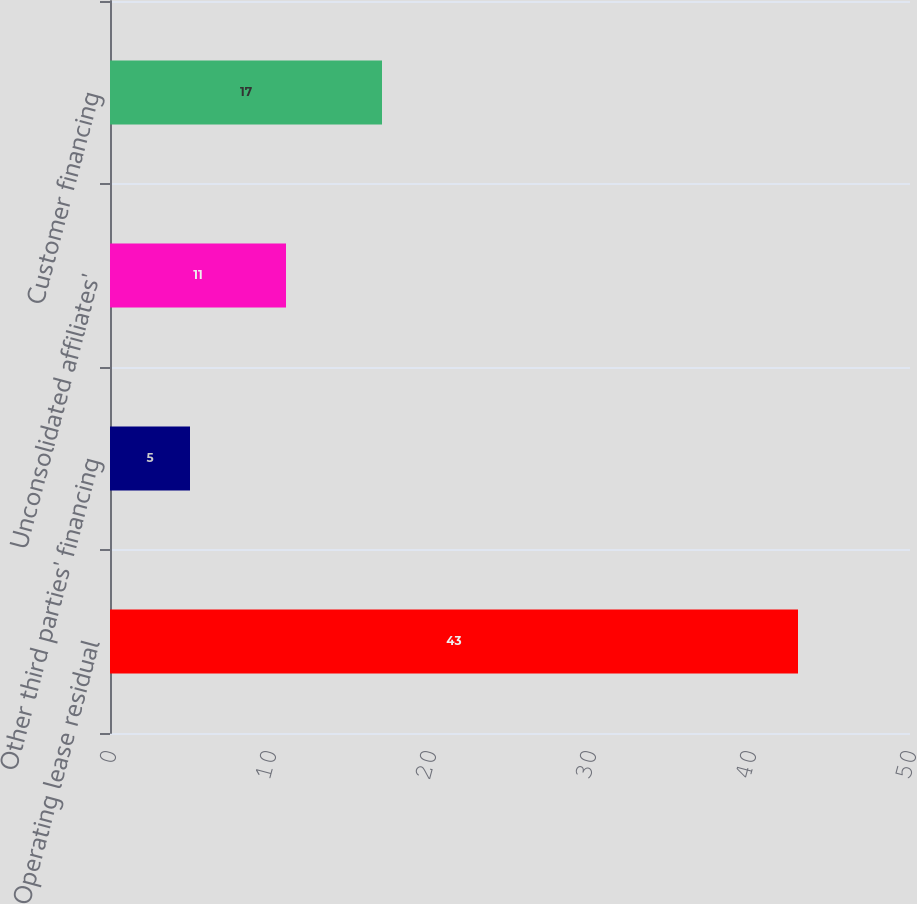Convert chart to OTSL. <chart><loc_0><loc_0><loc_500><loc_500><bar_chart><fcel>Operating lease residual<fcel>Other third parties' financing<fcel>Unconsolidated affiliates'<fcel>Customer financing<nl><fcel>43<fcel>5<fcel>11<fcel>17<nl></chart> 